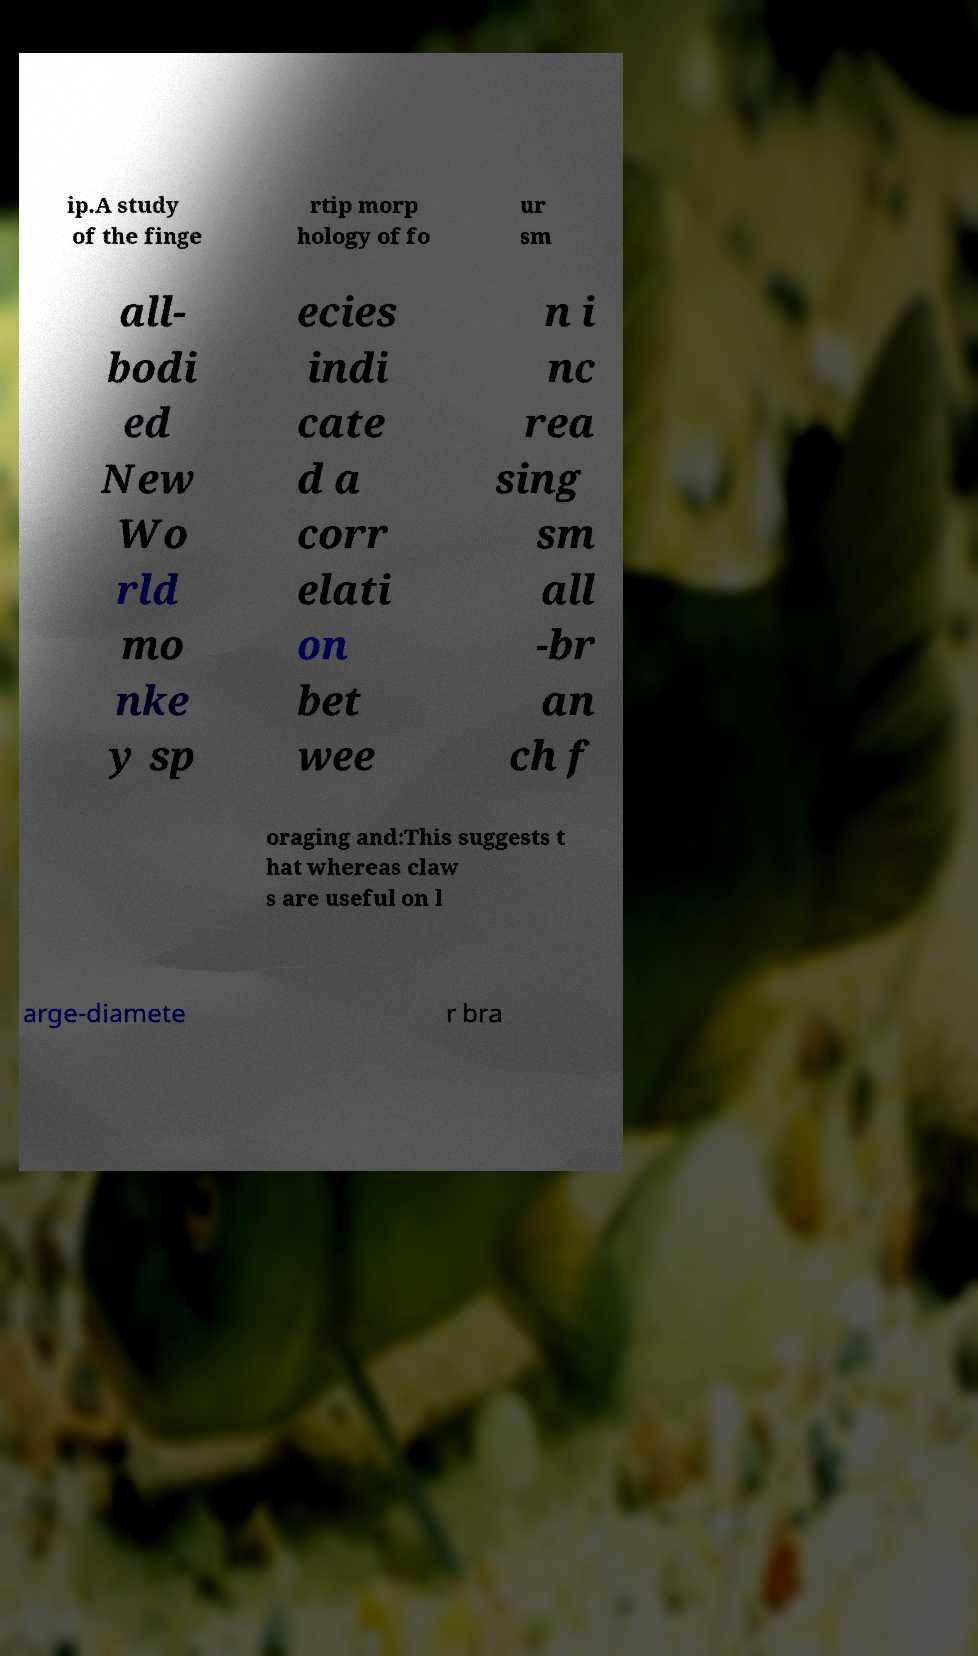There's text embedded in this image that I need extracted. Can you transcribe it verbatim? ip.A study of the finge rtip morp hology of fo ur sm all- bodi ed New Wo rld mo nke y sp ecies indi cate d a corr elati on bet wee n i nc rea sing sm all -br an ch f oraging and:This suggests t hat whereas claw s are useful on l arge-diamete r bra 